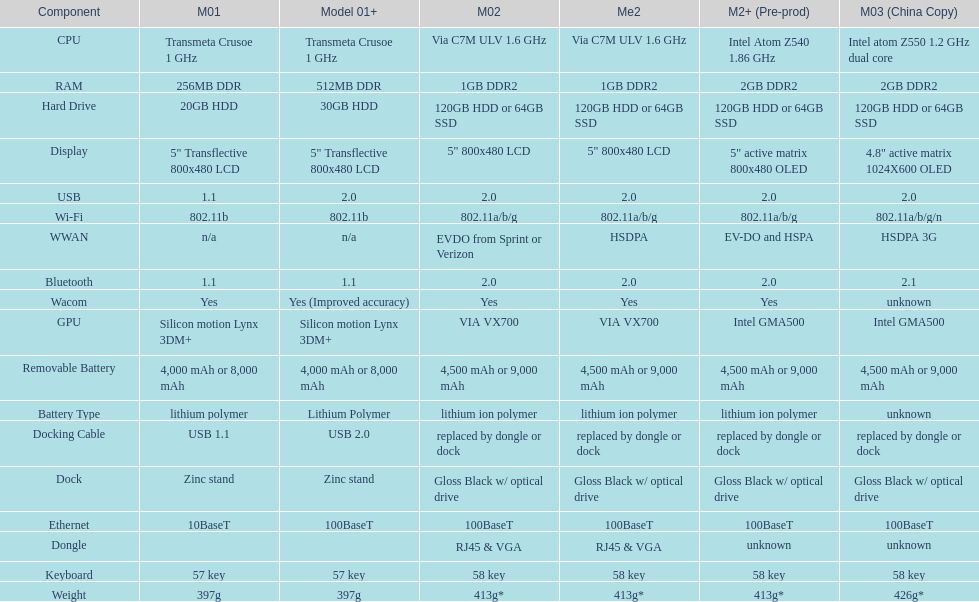For how many models is a usb docking cable used? 2. 